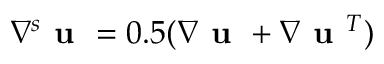Convert formula to latex. <formula><loc_0><loc_0><loc_500><loc_500>\nabla ^ { s } u = 0 . 5 ( \nabla u + \nabla u ^ { T } )</formula> 